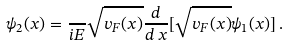Convert formula to latex. <formula><loc_0><loc_0><loc_500><loc_500>\psi _ { 2 } ( x ) = \frac { } { i E } \sqrt { v _ { F } ( x ) } \frac { d } { d \, x } [ \sqrt { v _ { F } ( x ) } \psi _ { 1 } ( x ) ] \, .</formula> 